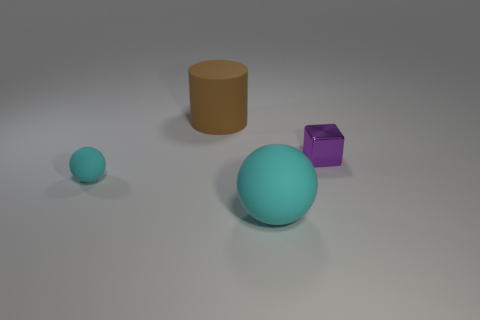How many other things are the same color as the large sphere?
Your response must be concise. 1. Does the small sphere have the same color as the large rubber object that is in front of the small cyan matte object?
Provide a succinct answer. Yes. Is the brown thing made of the same material as the tiny thing behind the small matte ball?
Keep it short and to the point. No. What is the color of the matte thing that is left of the big cyan ball and in front of the purple thing?
Provide a succinct answer. Cyan. Are there any big matte things that have the same shape as the tiny cyan thing?
Ensure brevity in your answer.  Yes. Is the color of the tiny matte object the same as the big ball?
Your response must be concise. Yes. Are there any brown rubber cylinders in front of the big thing in front of the brown rubber thing?
Your answer should be compact. No. What number of objects are objects that are behind the shiny cube or rubber things behind the small block?
Provide a succinct answer. 1. What number of things are either matte balls or big rubber objects that are in front of the block?
Your answer should be very brief. 2. There is a cyan rubber object that is behind the big object that is in front of the big thing that is to the left of the big rubber sphere; what is its size?
Provide a succinct answer. Small. 